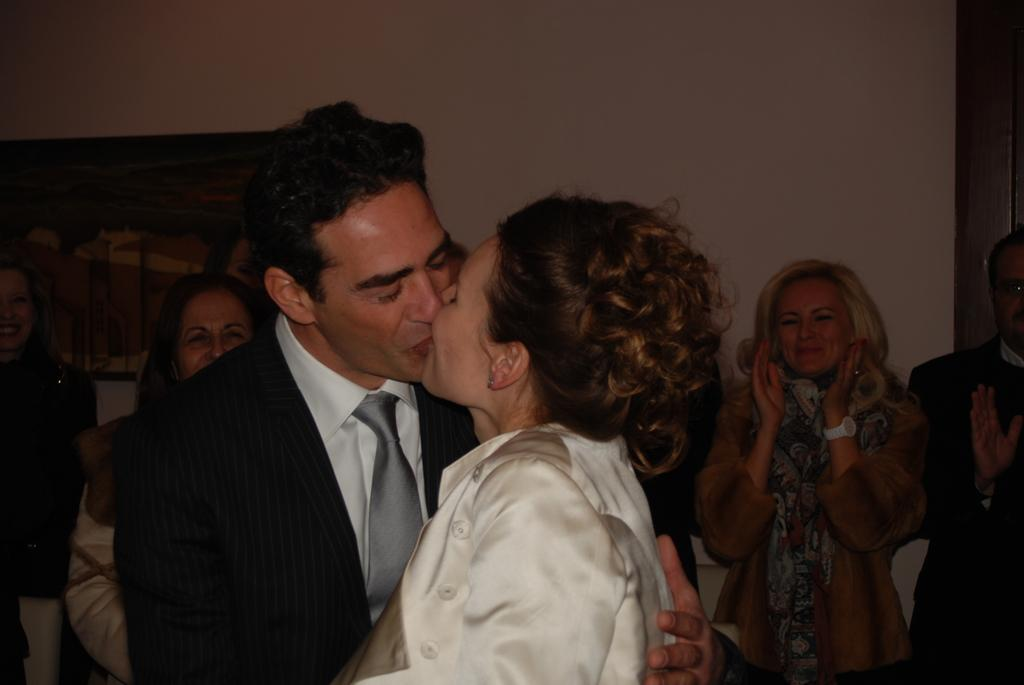Who are the two people in the image? There is a man and a woman in the image. What are the man and woman doing in the image? The man and woman are standing and kissing each other. What is the mood of the other people in the image? There are people standing and smiling in the image. Where is the photo frame located? The photo frame is attached to a wall. What type of bell can be heard ringing in the image? There is no bell present in the image, and therefore no sound can be heard. 